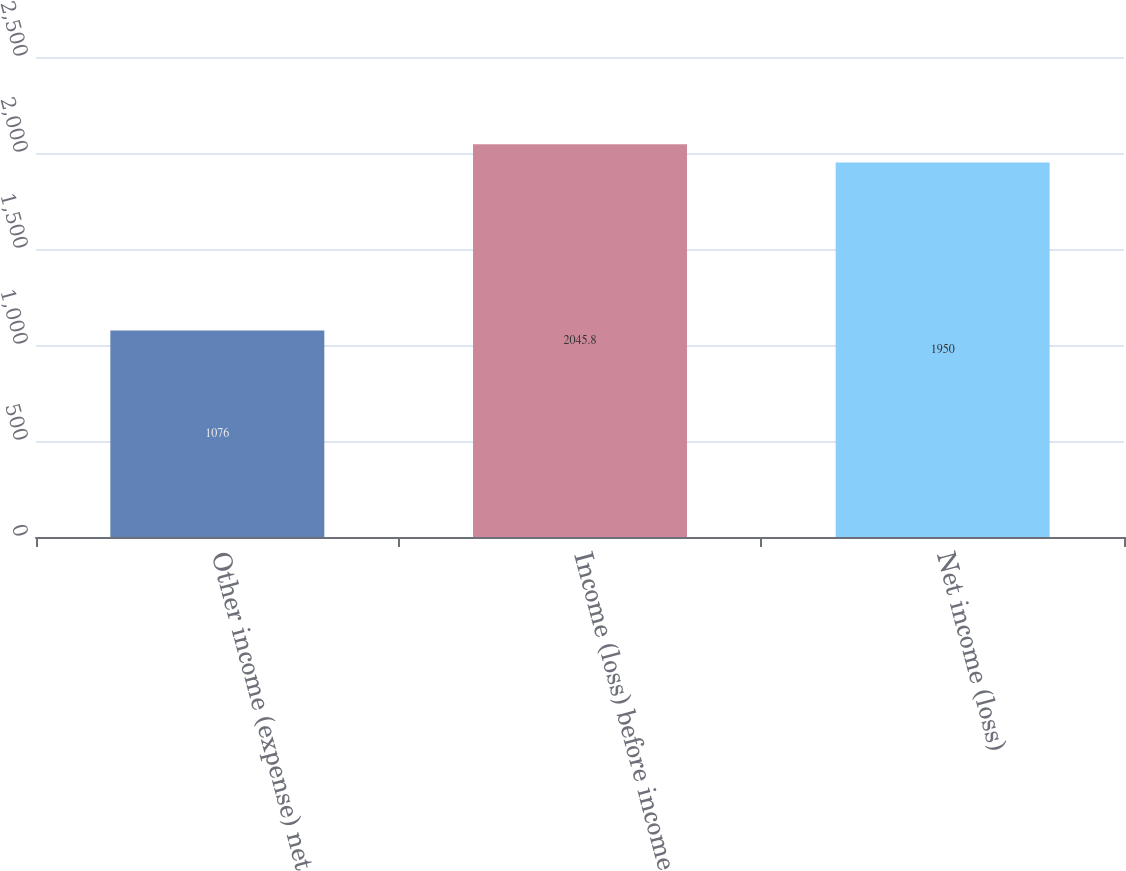Convert chart to OTSL. <chart><loc_0><loc_0><loc_500><loc_500><bar_chart><fcel>Other income (expense) net<fcel>Income (loss) before income<fcel>Net income (loss)<nl><fcel>1076<fcel>2045.8<fcel>1950<nl></chart> 